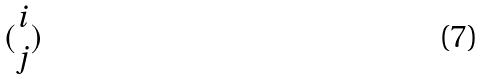Convert formula to latex. <formula><loc_0><loc_0><loc_500><loc_500>( \begin{matrix} i \\ j \end{matrix} )</formula> 